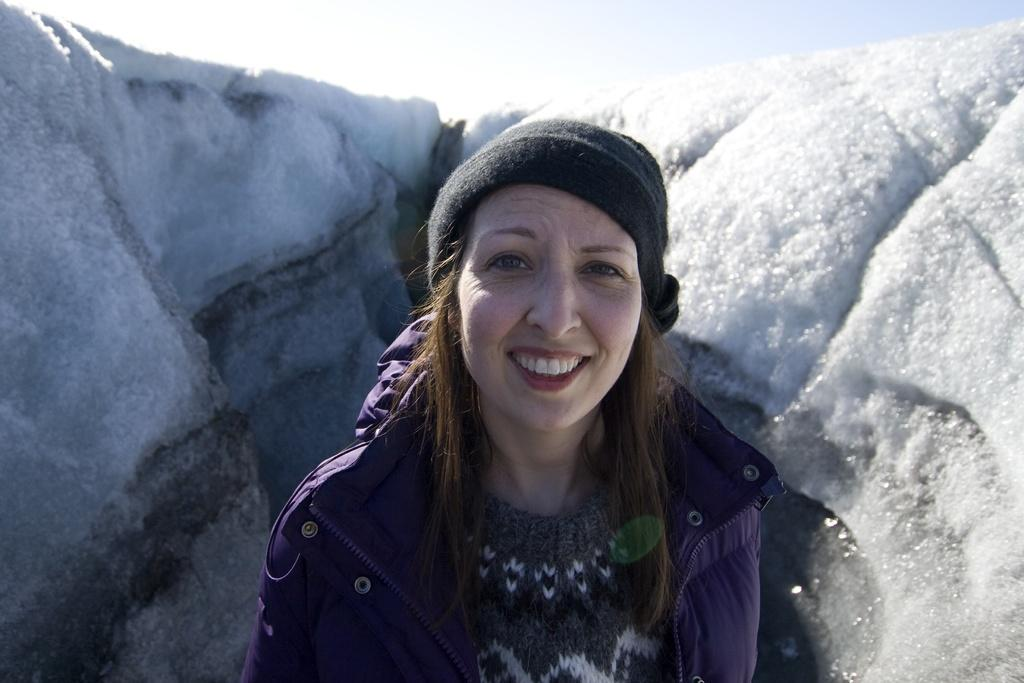Who is present in the image? There is a woman in the image. What is the woman wearing on her head? The woman is wearing a cap. What type of clothing is the woman wearing on her upper body? The woman is wearing a jacket. What is the woman's facial expression in the image? The woman is smiling. What can be seen in the background of the image? There is snow and sky visible in the background of the image. Can you see any grapes hanging from the woman's jacket in the image? There are no grapes visible in the image; the woman is wearing a jacket and a cap. Is there a hose connected to the woman's cap in the image? There is no hose present in the image; the woman is simply wearing a cap. 